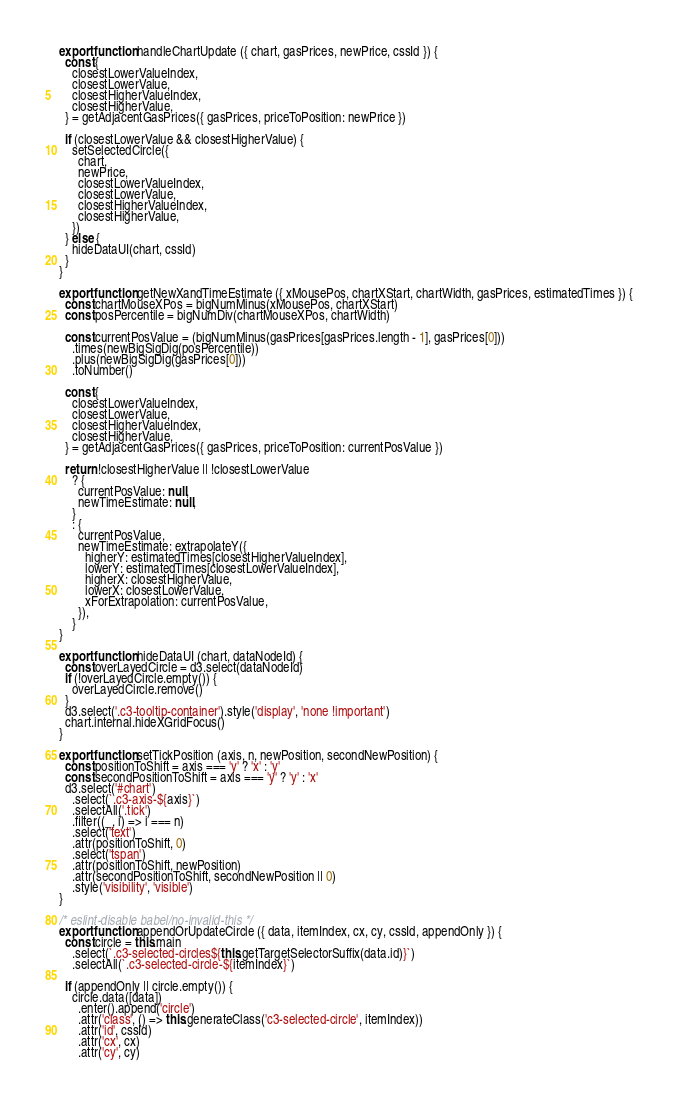Convert code to text. <code><loc_0><loc_0><loc_500><loc_500><_JavaScript_>export function handleChartUpdate ({ chart, gasPrices, newPrice, cssId }) {
  const {
    closestLowerValueIndex,
    closestLowerValue,
    closestHigherValueIndex,
    closestHigherValue,
  } = getAdjacentGasPrices({ gasPrices, priceToPosition: newPrice })

  if (closestLowerValue && closestHigherValue) {
    setSelectedCircle({
      chart,
      newPrice,
      closestLowerValueIndex,
      closestLowerValue,
      closestHigherValueIndex,
      closestHigherValue,
    })
  } else {
    hideDataUI(chart, cssId)
  }
}

export function getNewXandTimeEstimate ({ xMousePos, chartXStart, chartWidth, gasPrices, estimatedTimes }) {
  const chartMouseXPos = bigNumMinus(xMousePos, chartXStart)
  const posPercentile = bigNumDiv(chartMouseXPos, chartWidth)

  const currentPosValue = (bigNumMinus(gasPrices[gasPrices.length - 1], gasPrices[0]))
    .times(newBigSigDig(posPercentile))
    .plus(newBigSigDig(gasPrices[0]))
    .toNumber()

  const {
    closestLowerValueIndex,
    closestLowerValue,
    closestHigherValueIndex,
    closestHigherValue,
  } = getAdjacentGasPrices({ gasPrices, priceToPosition: currentPosValue })

  return !closestHigherValue || !closestLowerValue
    ? {
      currentPosValue: null,
      newTimeEstimate: null,
    }
    : {
      currentPosValue,
      newTimeEstimate: extrapolateY({
        higherY: estimatedTimes[closestHigherValueIndex],
        lowerY: estimatedTimes[closestLowerValueIndex],
        higherX: closestHigherValue,
        lowerX: closestLowerValue,
        xForExtrapolation: currentPosValue,
      }),
    }
}

export function hideDataUI (chart, dataNodeId) {
  const overLayedCircle = d3.select(dataNodeId)
  if (!overLayedCircle.empty()) {
    overLayedCircle.remove()
  }
  d3.select('.c3-tooltip-container').style('display', 'none !important')
  chart.internal.hideXGridFocus()
}

export function setTickPosition (axis, n, newPosition, secondNewPosition) {
  const positionToShift = axis === 'y' ? 'x' : 'y'
  const secondPositionToShift = axis === 'y' ? 'y' : 'x'
  d3.select('#chart')
    .select(`.c3-axis-${axis}`)
    .selectAll('.tick')
    .filter((_, i) => i === n)
    .select('text')
    .attr(positionToShift, 0)
    .select('tspan')
    .attr(positionToShift, newPosition)
    .attr(secondPositionToShift, secondNewPosition || 0)
    .style('visibility', 'visible')
}

/* eslint-disable babel/no-invalid-this */
export function appendOrUpdateCircle ({ data, itemIndex, cx, cy, cssId, appendOnly }) {
  const circle = this.main
    .select(`.c3-selected-circles${this.getTargetSelectorSuffix(data.id)}`)
    .selectAll(`.c3-selected-circle-${itemIndex}`)

  if (appendOnly || circle.empty()) {
    circle.data([data])
      .enter().append('circle')
      .attr('class', () => this.generateClass('c3-selected-circle', itemIndex))
      .attr('id', cssId)
      .attr('cx', cx)
      .attr('cy', cy)</code> 